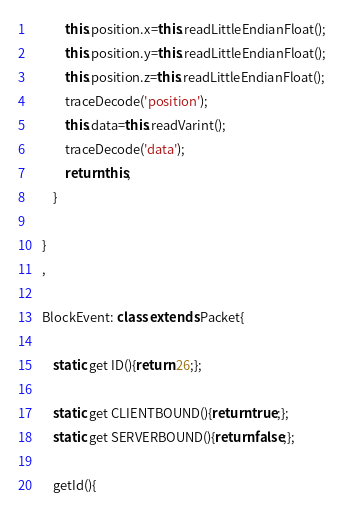<code> <loc_0><loc_0><loc_500><loc_500><_JavaScript_>			this.position.x=this.readLittleEndianFloat();
			this.position.y=this.readLittleEndianFloat();
			this.position.z=this.readLittleEndianFloat();
			traceDecode('position');
			this.data=this.readVarint();
			traceDecode('data');
			return this;
		}

	}
	,

	BlockEvent: class extends Packet{

		static get ID(){return 26;};

		static get CLIENTBOUND(){return true;};
		static get SERVERBOUND(){return false;};

		getId(){</code> 